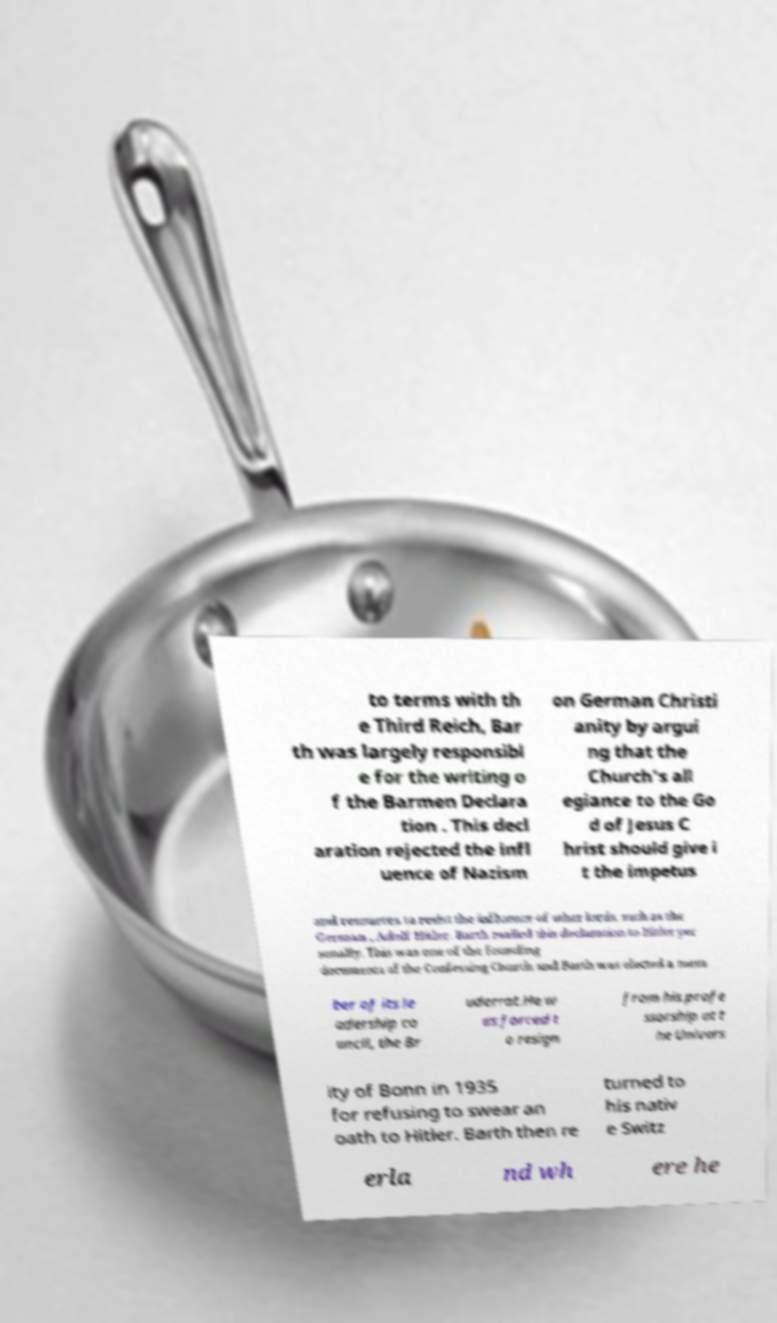I need the written content from this picture converted into text. Can you do that? to terms with th e Third Reich, Bar th was largely responsibl e for the writing o f the Barmen Declara tion . This decl aration rejected the infl uence of Nazism on German Christi anity by argui ng that the Church's all egiance to the Go d of Jesus C hrist should give i t the impetus and resources to resist the influence of other lords, such as the German , Adolf Hitler. Barth mailed this declaration to Hitler per sonally. This was one of the founding documents of the Confessing Church and Barth was elected a mem ber of its le adership co uncil, the Br uderrat.He w as forced t o resign from his profe ssorship at t he Univers ity of Bonn in 1935 for refusing to swear an oath to Hitler. Barth then re turned to his nativ e Switz erla nd wh ere he 